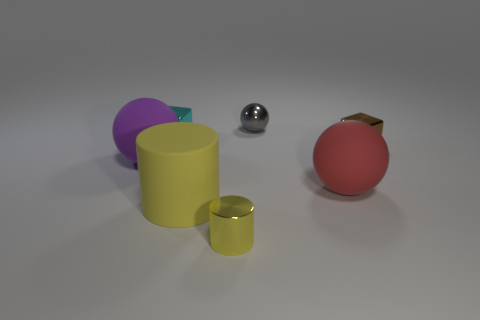Subtract all large matte spheres. How many spheres are left? 1 Add 1 tiny spheres. How many objects exist? 8 Subtract all cubes. How many objects are left? 5 Subtract all brown cubes. How many cubes are left? 1 Subtract 1 spheres. How many spheres are left? 2 Subtract 1 purple balls. How many objects are left? 6 Subtract all brown cylinders. Subtract all purple cubes. How many cylinders are left? 2 Subtract all red balls. How many gray cylinders are left? 0 Subtract all small purple cylinders. Subtract all small cyan cubes. How many objects are left? 6 Add 5 small yellow things. How many small yellow things are left? 6 